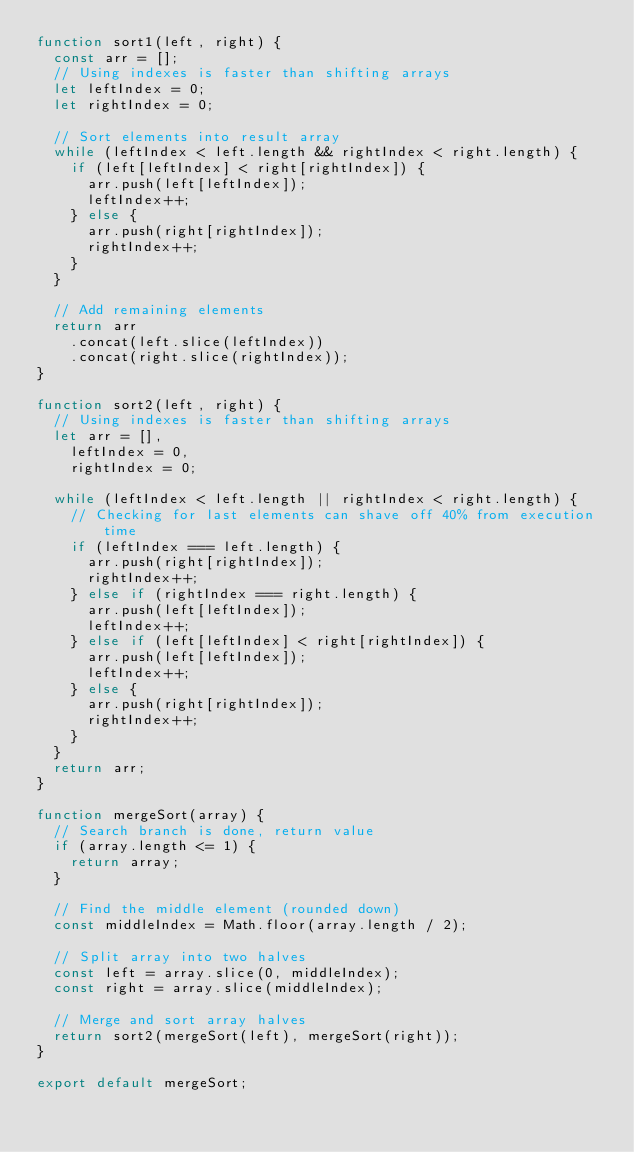Convert code to text. <code><loc_0><loc_0><loc_500><loc_500><_JavaScript_>function sort1(left, right) {
  const arr = [];
  // Using indexes is faster than shifting arrays
  let leftIndex = 0;
  let rightIndex = 0;

  // Sort elements into result array
  while (leftIndex < left.length && rightIndex < right.length) {
    if (left[leftIndex] < right[rightIndex]) {
      arr.push(left[leftIndex]);
      leftIndex++;
    } else {
      arr.push(right[rightIndex]);
      rightIndex++;
    }
  }

  // Add remaining elements
  return arr
    .concat(left.slice(leftIndex))
    .concat(right.slice(rightIndex));
}

function sort2(left, right) {
  // Using indexes is faster than shifting arrays
  let arr = [],
    leftIndex = 0,
    rightIndex = 0;

  while (leftIndex < left.length || rightIndex < right.length) {
    // Checking for last elements can shave off 40% from execution time
    if (leftIndex === left.length) {
      arr.push(right[rightIndex]);
      rightIndex++;
    } else if (rightIndex === right.length) {
      arr.push(left[leftIndex]);
      leftIndex++;
    } else if (left[leftIndex] < right[rightIndex]) {
      arr.push(left[leftIndex]);
      leftIndex++;
    } else {
      arr.push(right[rightIndex]);
      rightIndex++;
    }
  }
  return arr;
}

function mergeSort(array) {
  // Search branch is done, return value
  if (array.length <= 1) {
    return array;
  }

  // Find the middle element (rounded down)
  const middleIndex = Math.floor(array.length / 2);

  // Split array into two halves
  const left = array.slice(0, middleIndex);
  const right = array.slice(middleIndex);

  // Merge and sort array halves
  return sort2(mergeSort(left), mergeSort(right));
}

export default mergeSort;
</code> 